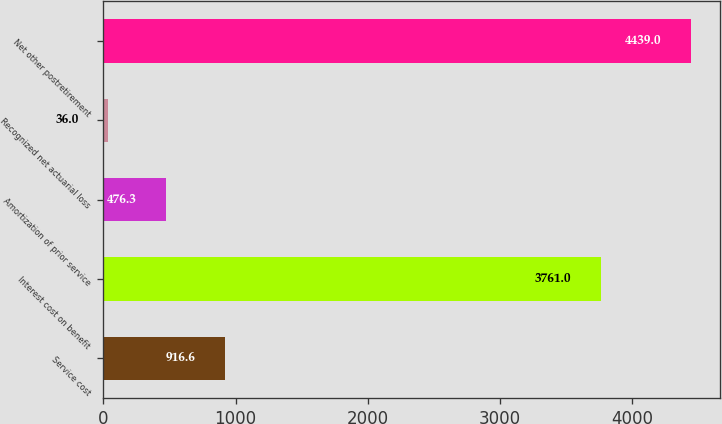Convert chart to OTSL. <chart><loc_0><loc_0><loc_500><loc_500><bar_chart><fcel>Service cost<fcel>Interest cost on benefit<fcel>Amortization of prior service<fcel>Recognized net actuarial loss<fcel>Net other postretirement<nl><fcel>916.6<fcel>3761<fcel>476.3<fcel>36<fcel>4439<nl></chart> 